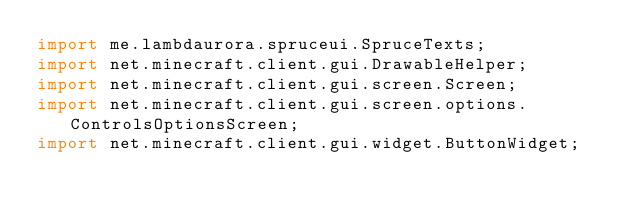Convert code to text. <code><loc_0><loc_0><loc_500><loc_500><_Java_>import me.lambdaurora.spruceui.SpruceTexts;
import net.minecraft.client.gui.DrawableHelper;
import net.minecraft.client.gui.screen.Screen;
import net.minecraft.client.gui.screen.options.ControlsOptionsScreen;
import net.minecraft.client.gui.widget.ButtonWidget;</code> 